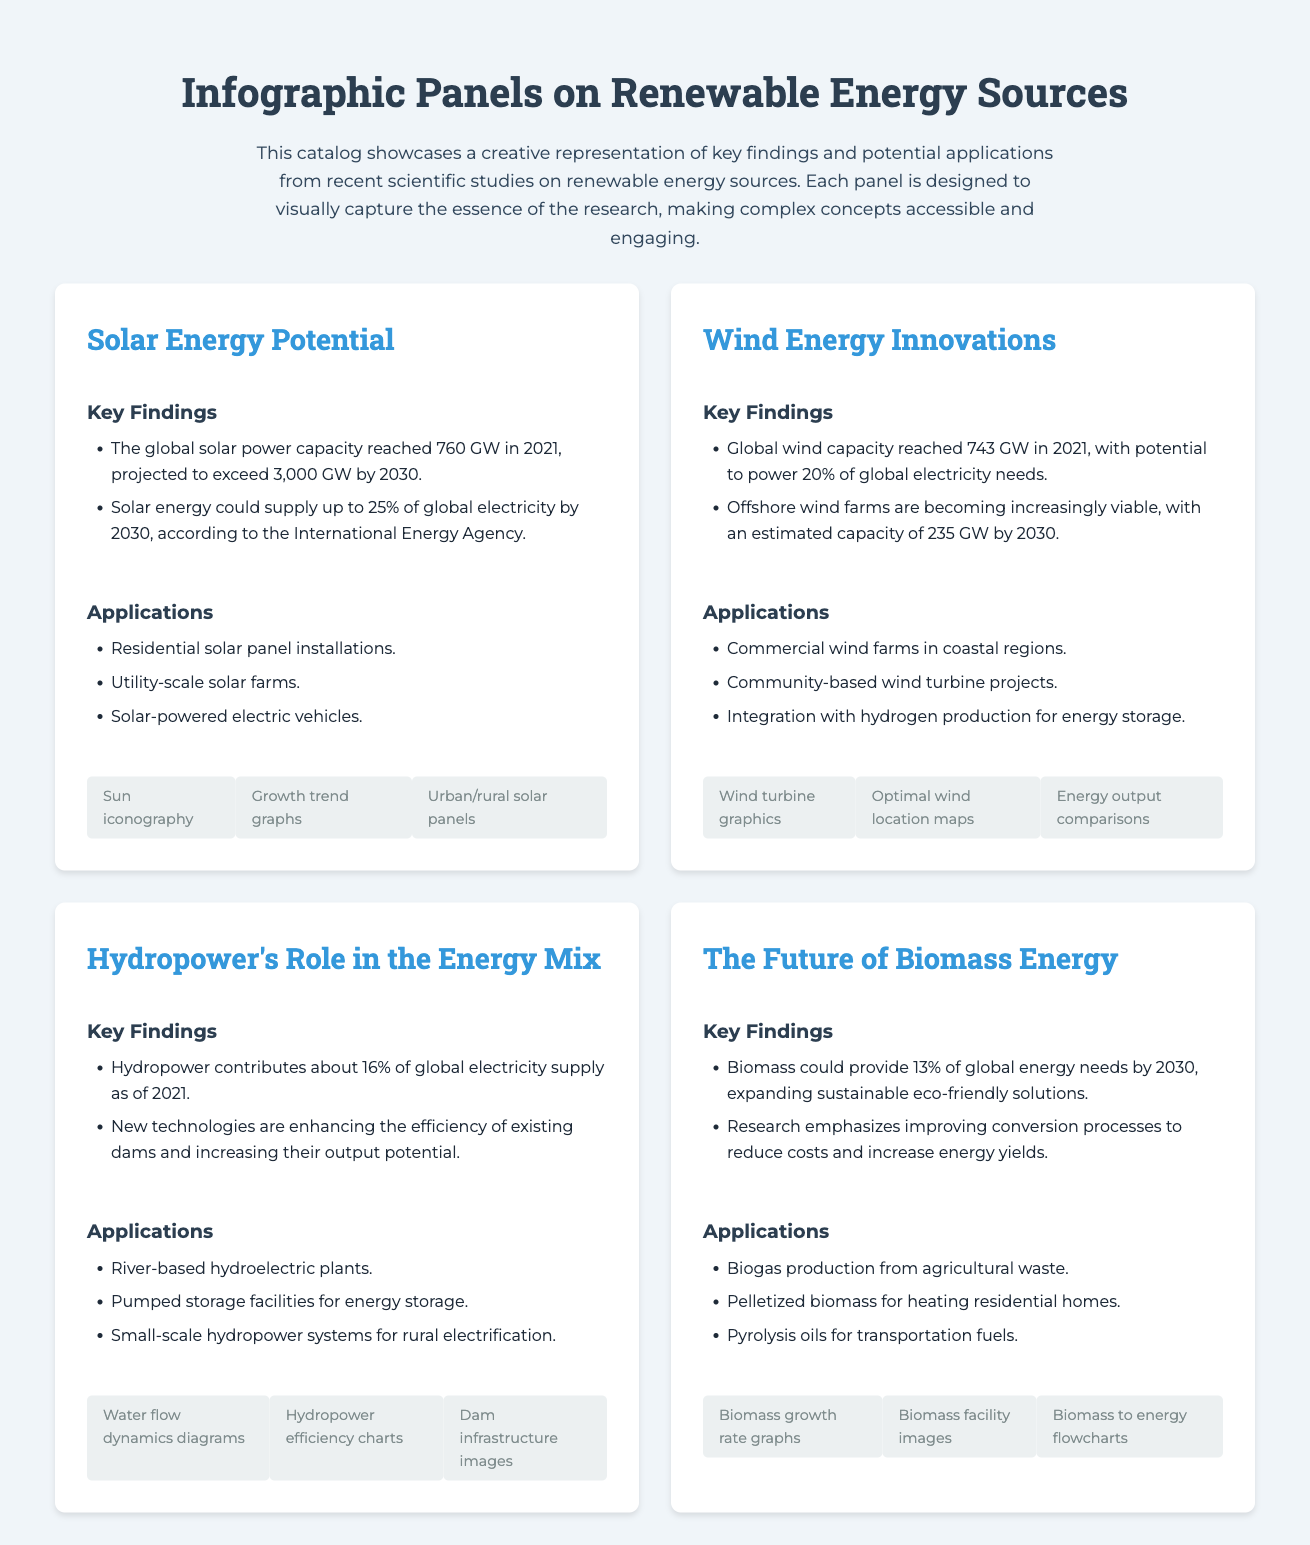What is the global solar power capacity in 2021? The document states that the global solar power capacity reached 760 GW in 2021.
Answer: 760 GW What percentage of global electricity could solar energy supply by 2030? According to the International Energy Agency, solar energy could supply up to 25% of global electricity by 2030.
Answer: 25% What is the projected global wind capacity by 2030? The document mentions an estimated capacity of 235 GW by 2030 for offshore wind farms.
Answer: 235 GW How much of the global electricity supply does hydropower contribute as of 2021? The document states that hydropower contributes about 16% of global electricity supply as of 2021.
Answer: 16% What is a key application of biomass energy mentioned in the document? One of the key applications mentioned is biogas production from agricultural waste.
Answer: Biogas production What unique visual element is included in the solar energy panel? The solar energy panel includes sun iconography as a visual element.
Answer: Sun iconography Which renewable energy sources panel highlights community-based projects? The wind energy innovations panel highlights community-based wind turbine projects.
Answer: Wind energy innovations What is one of the key findings regarding biomass energy? The document states that biomass could provide 13% of global energy needs by 2030.
Answer: 13% What type of infographic panels does this document showcase? The document showcases infographic panels on renewable energy sources.
Answer: Renewable energy sources What technology is mentioned to enhance hydropower efficiency? The document refers to new technologies that are enhancing the efficiency of existing dams.
Answer: New technologies 